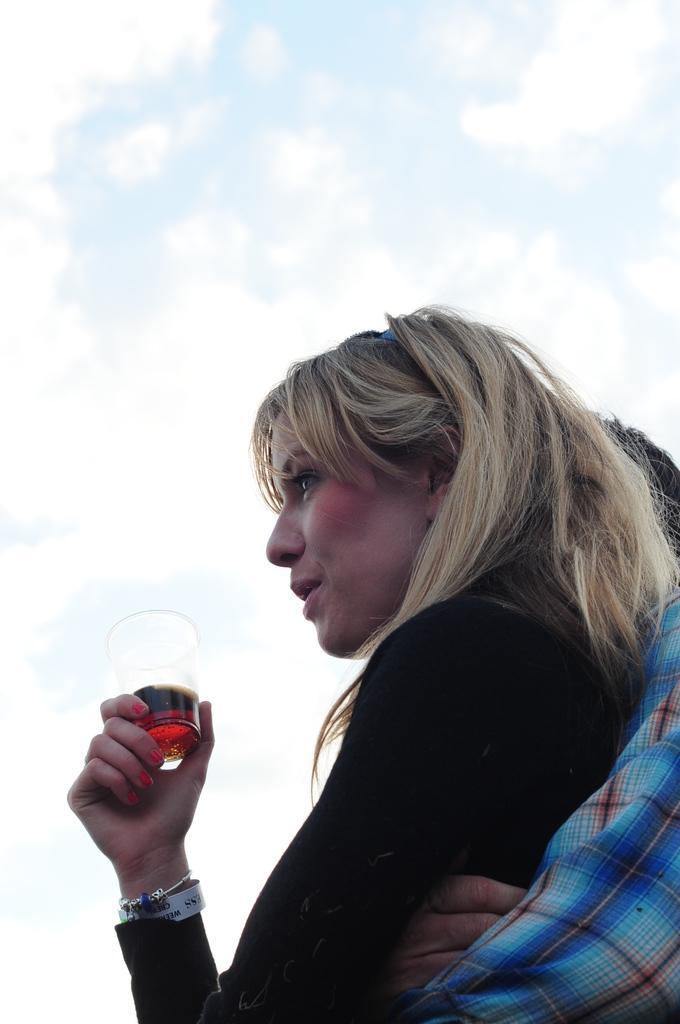Describe this image in one or two sentences. In this image there is one man and one woman and woman is holding a glass, and in the glass there is a drink. At the top there is sky. 